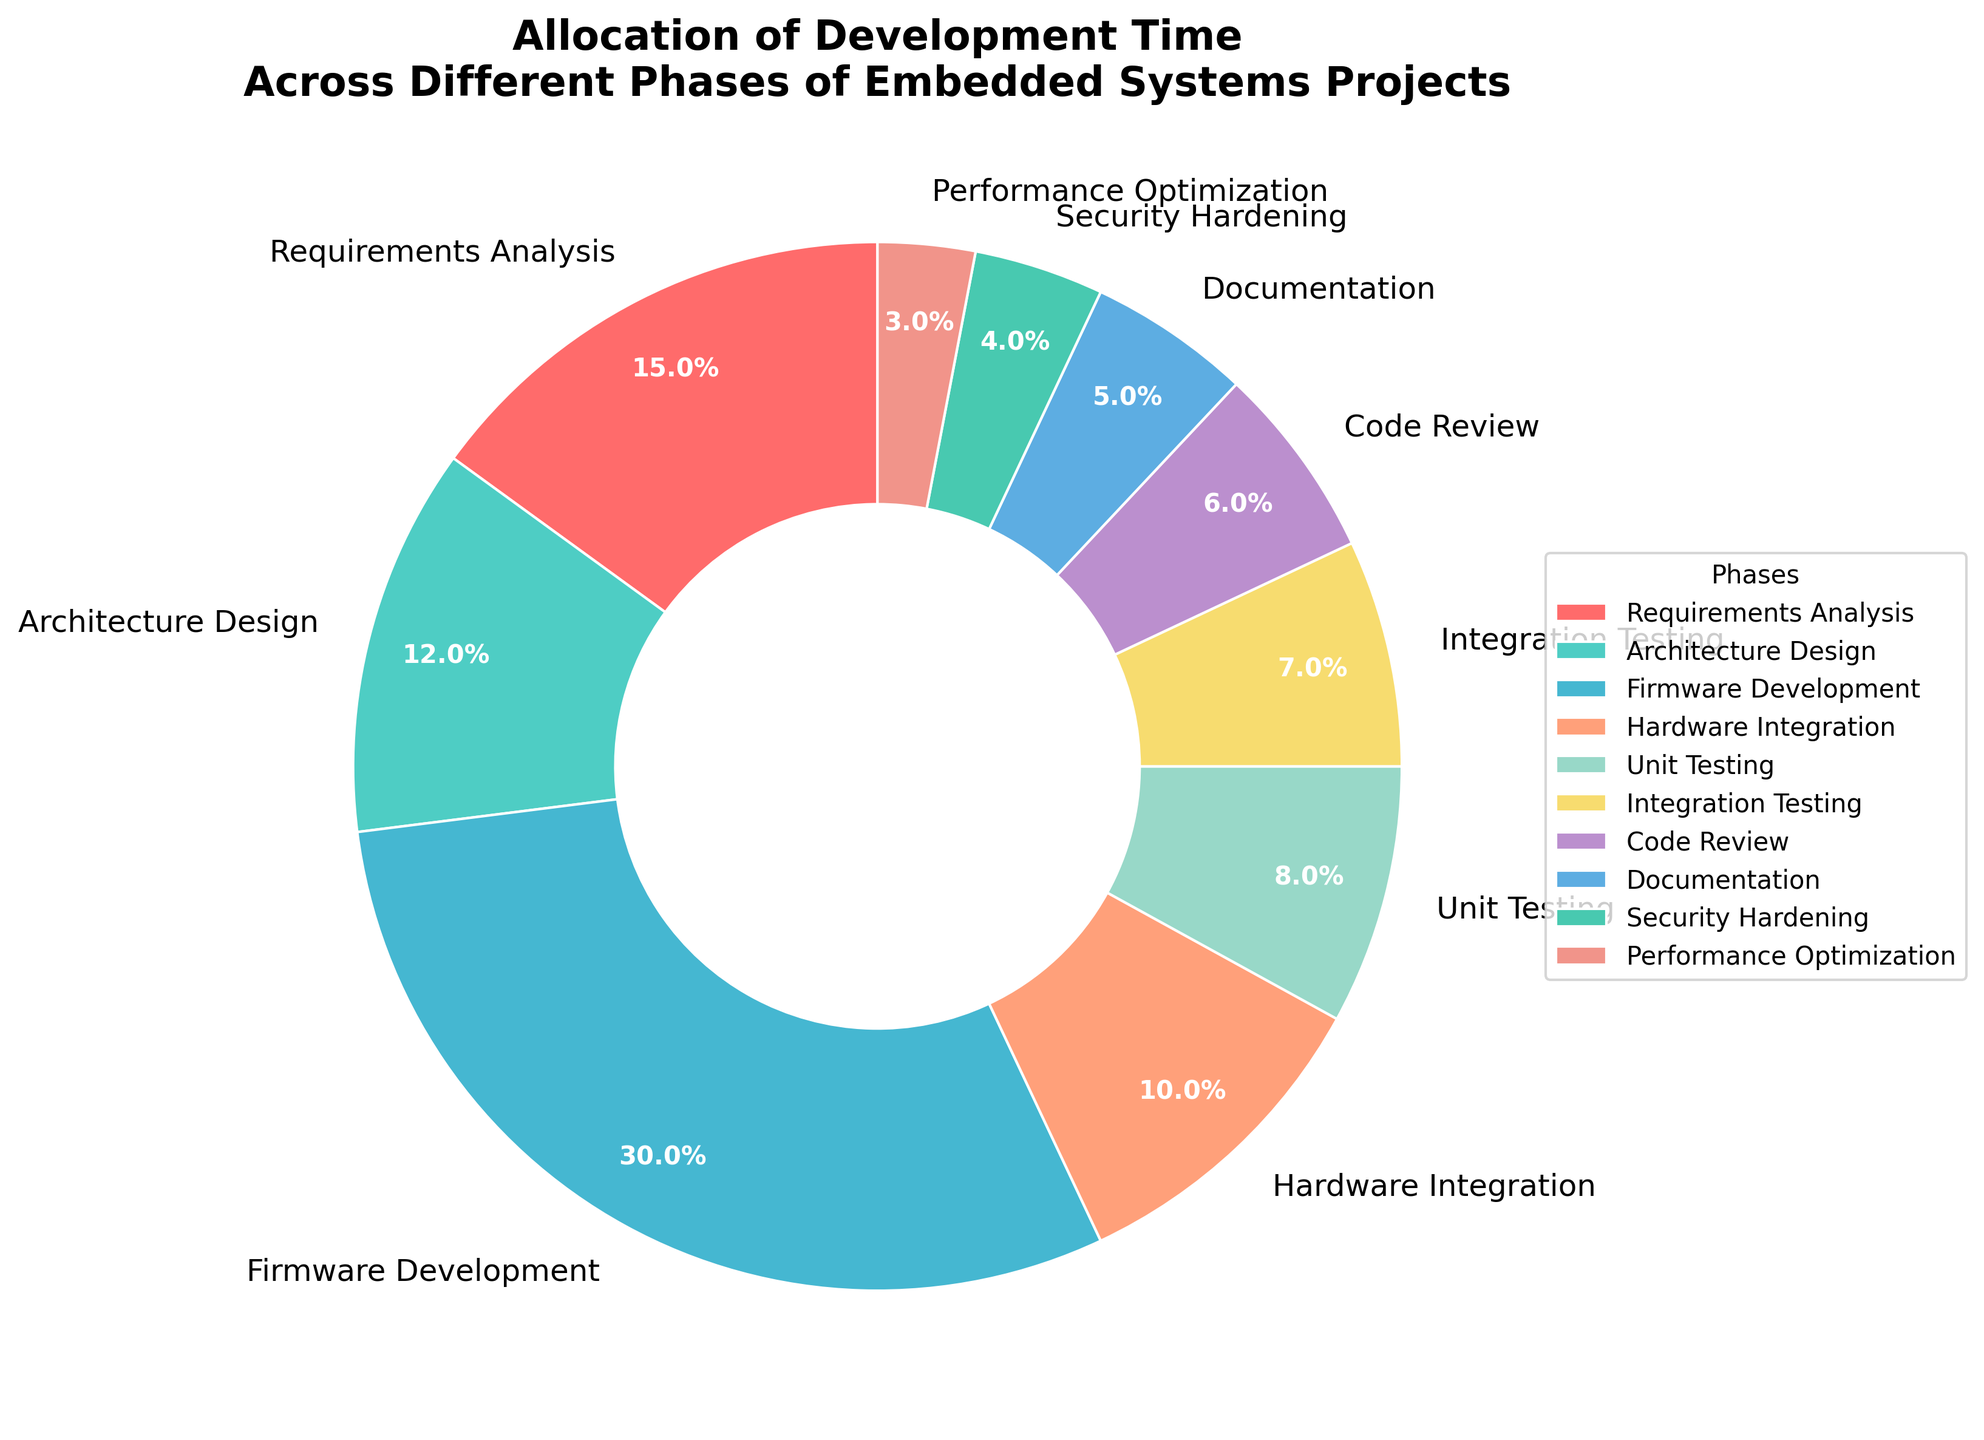What phase consumes the highest percentage of development time? By looking at the pie chart, the phase that occupies the largest segment represents the highest percentage of development time. "Firmware Development" has the largest segment, indicating it consumes the highest percentage, which is 30%.
Answer: Firmware Development Which phase has the least allocation of development time? By observing the pie chart, the smallest segment corresponds to the phase with the least allocation of development time. "Performance Optimization" has the smallest segment at 3%.
Answer: Performance Optimization Comparing Architecture Design and Unit Testing, which phase requires more development time? The chart shows that Architecture Design is allocated 12% while Unit Testing is allocated 8%. Therefore, Architecture Design requires more development time than Unit Testing.
Answer: Architecture Design What is the combined percentage of development time allocated to Hardware Integration and Integration Testing? The chart shows Hardware Integration with 10% and Integration Testing with 7%. Adding these percentages gives 10% + 7% = 17%.
Answer: 17% Is the time allocated to Code Review greater than the time allocated to Documentation? The pie chart shows Code Review at 6% and Documentation at 5%. Since 6% is greater than 5%, Code Review has more allocated time than Documentation.
Answer: Yes What is the sum of the percentages allocated to Firmware Development and Requirements Analysis? From the pie chart, Firmware Development takes 30% and Requirements Analysis takes 15%. Adding these together, 30% + 15% = 45%.
Answer: 45% Which phases combined take up less than 10% of development time each? Observing the segments, the phases with a percentage less than 10% are Unit Testing (8%), Integration Testing (7%), Code Review (6%), Documentation (5%), Security Hardening (4%), and Performance Optimization (3%).
Answer: Unit Testing, Integration Testing, Code Review, Documentation, Security Hardening, Performance Optimization How much more time is allocated to Firmware Development compared to Unit Testing? According to the pie chart, Firmware Development is allocated 30% and Unit Testing is allocated 8%. The difference is 30% - 8% = 22%.
Answer: 22% What color segment represents Security Hardening? The color of each segment corresponds to a specific phase, and observing the legend in the pie chart, Security Hardening is represented by a green color.
Answer: Green 